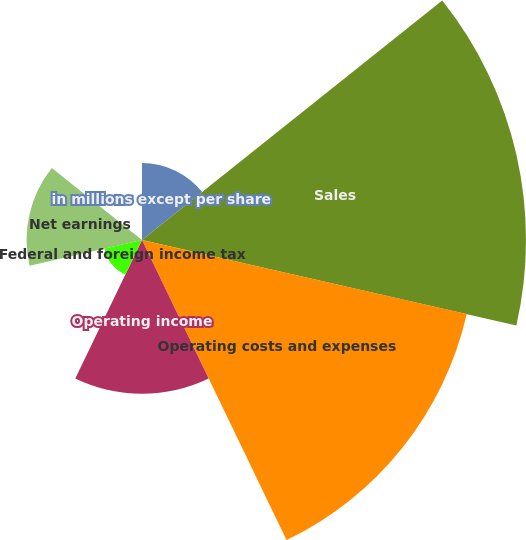Convert chart. <chart><loc_0><loc_0><loc_500><loc_500><pie_chart><fcel>in millions except per share<fcel>Sales<fcel>Operating costs and expenses<fcel>Operating income<fcel>Federal and foreign income tax<fcel>Net earnings<fcel>Diluted earnings per share<nl><fcel>6.98%<fcel>34.85%<fcel>30.23%<fcel>13.95%<fcel>3.5%<fcel>10.47%<fcel>0.02%<nl></chart> 